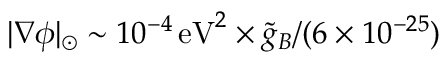Convert formula to latex. <formula><loc_0><loc_0><loc_500><loc_500>| \nabla \phi | _ { \odot } \sim 1 0 ^ { - 4 } \, e V ^ { 2 } \times { \tilde { g } _ { B } } / ( 6 \times 1 0 ^ { - 2 5 } )</formula> 